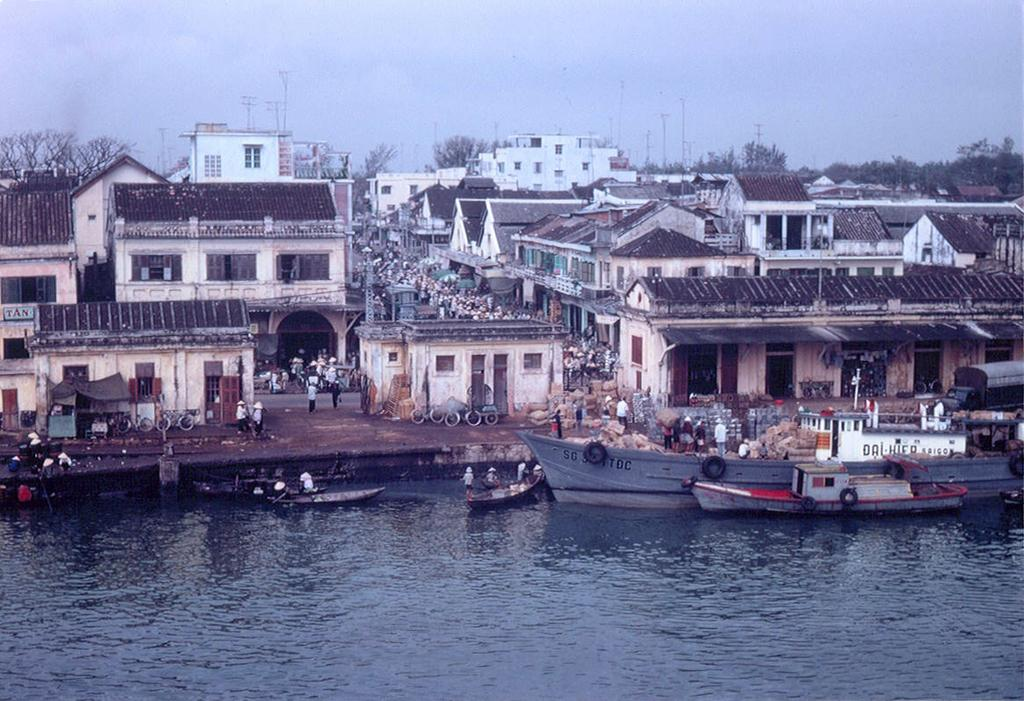What is the main structure in the image? There is a building in the image. What can be seen in front of the building? There are persons in front of the building. What natural feature is present in the image? There is a lake in the image. What is on the lake? There are boats on the lake. Can you show me the map that the persons are holding in the image? There is no map present in the image; the persons are not holding one. 